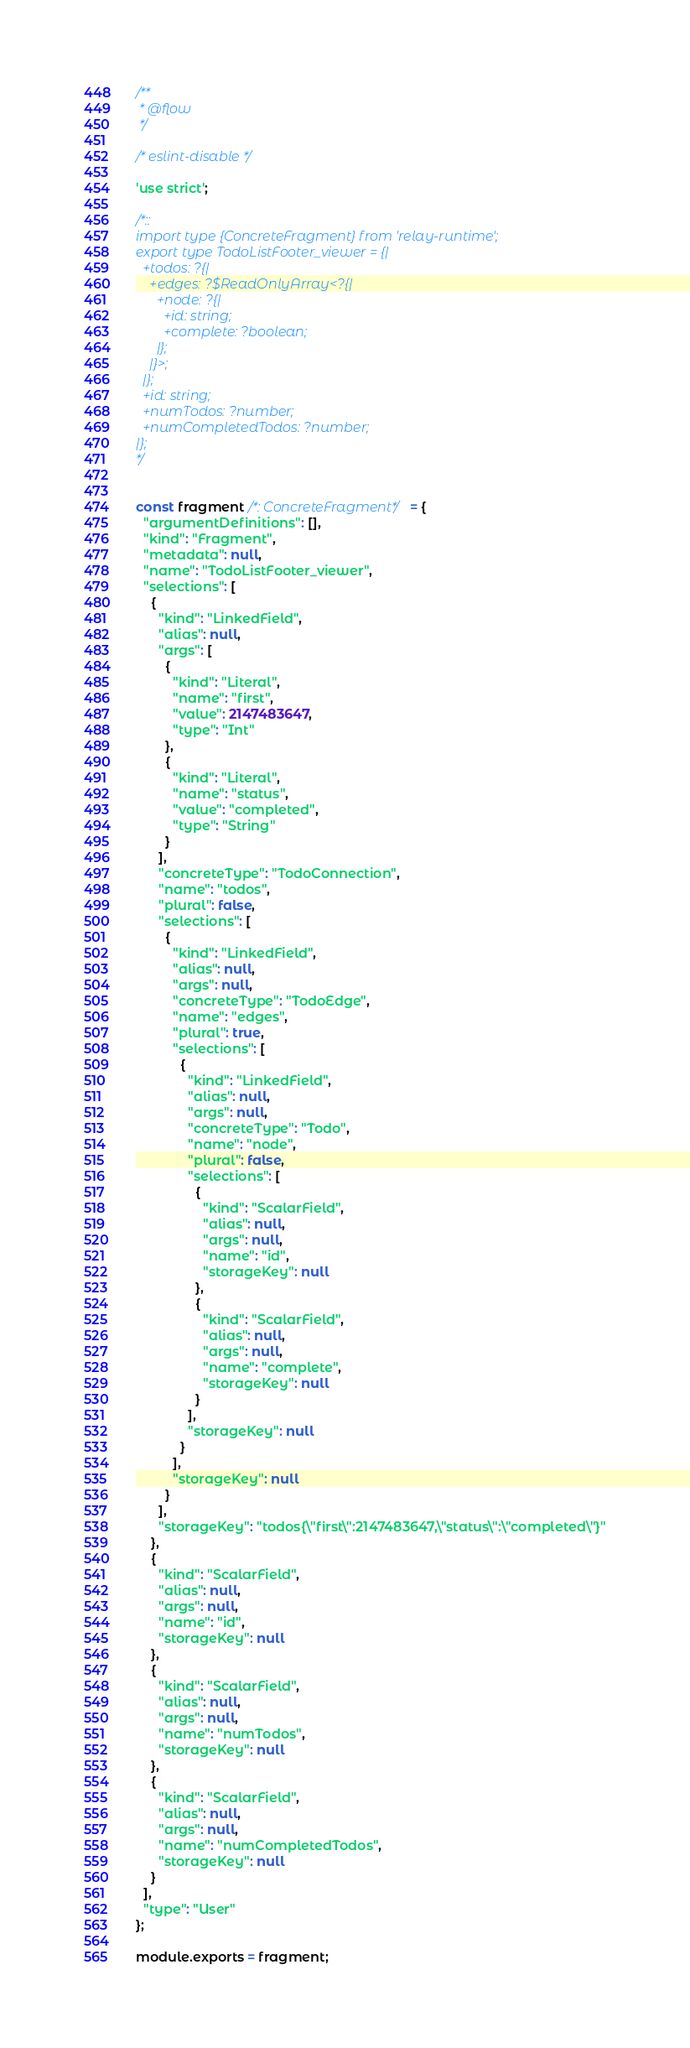Convert code to text. <code><loc_0><loc_0><loc_500><loc_500><_JavaScript_>/**
 * @flow
 */

/* eslint-disable */

'use strict';

/*::
import type {ConcreteFragment} from 'relay-runtime';
export type TodoListFooter_viewer = {|
  +todos: ?{|
    +edges: ?$ReadOnlyArray<?{|
      +node: ?{|
        +id: string;
        +complete: ?boolean;
      |};
    |}>;
  |};
  +id: string;
  +numTodos: ?number;
  +numCompletedTodos: ?number;
|};
*/


const fragment /*: ConcreteFragment*/ = {
  "argumentDefinitions": [],
  "kind": "Fragment",
  "metadata": null,
  "name": "TodoListFooter_viewer",
  "selections": [
    {
      "kind": "LinkedField",
      "alias": null,
      "args": [
        {
          "kind": "Literal",
          "name": "first",
          "value": 2147483647,
          "type": "Int"
        },
        {
          "kind": "Literal",
          "name": "status",
          "value": "completed",
          "type": "String"
        }
      ],
      "concreteType": "TodoConnection",
      "name": "todos",
      "plural": false,
      "selections": [
        {
          "kind": "LinkedField",
          "alias": null,
          "args": null,
          "concreteType": "TodoEdge",
          "name": "edges",
          "plural": true,
          "selections": [
            {
              "kind": "LinkedField",
              "alias": null,
              "args": null,
              "concreteType": "Todo",
              "name": "node",
              "plural": false,
              "selections": [
                {
                  "kind": "ScalarField",
                  "alias": null,
                  "args": null,
                  "name": "id",
                  "storageKey": null
                },
                {
                  "kind": "ScalarField",
                  "alias": null,
                  "args": null,
                  "name": "complete",
                  "storageKey": null
                }
              ],
              "storageKey": null
            }
          ],
          "storageKey": null
        }
      ],
      "storageKey": "todos{\"first\":2147483647,\"status\":\"completed\"}"
    },
    {
      "kind": "ScalarField",
      "alias": null,
      "args": null,
      "name": "id",
      "storageKey": null
    },
    {
      "kind": "ScalarField",
      "alias": null,
      "args": null,
      "name": "numTodos",
      "storageKey": null
    },
    {
      "kind": "ScalarField",
      "alias": null,
      "args": null,
      "name": "numCompletedTodos",
      "storageKey": null
    }
  ],
  "type": "User"
};

module.exports = fragment;
</code> 